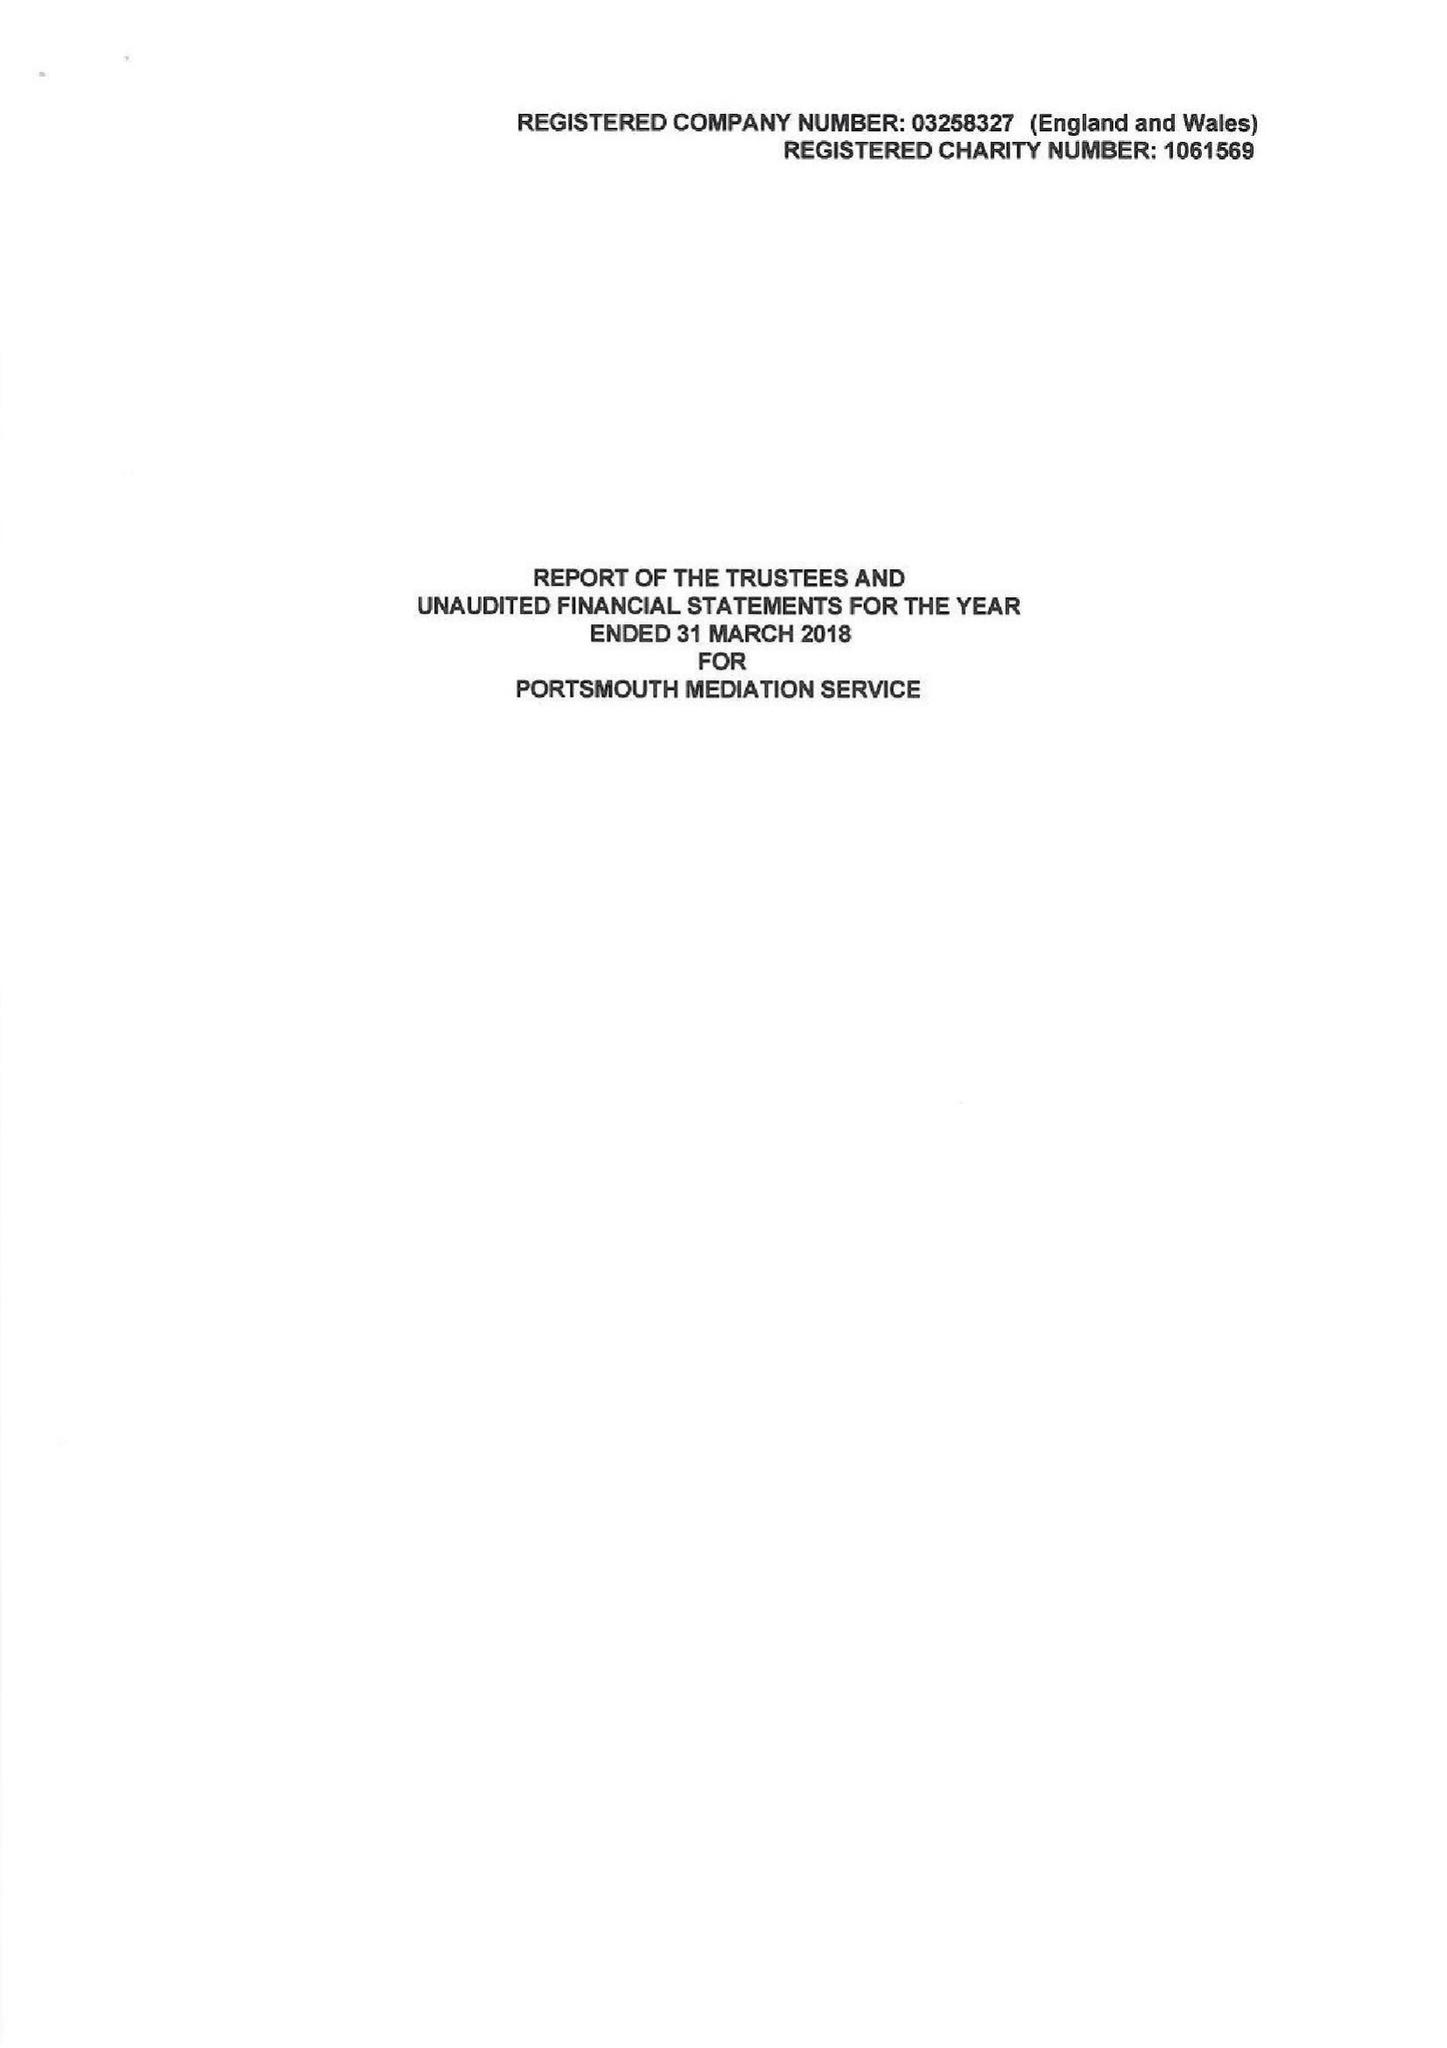What is the value for the charity_number?
Answer the question using a single word or phrase. 1061569 